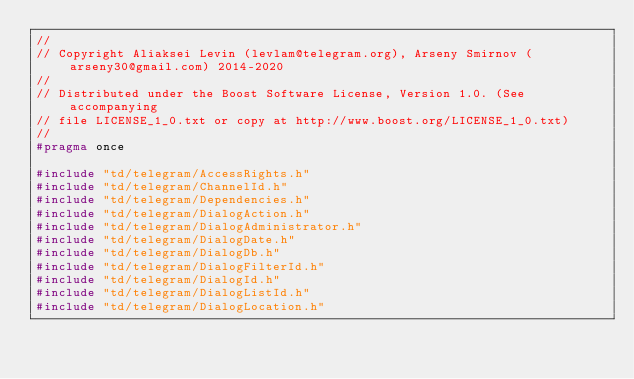<code> <loc_0><loc_0><loc_500><loc_500><_C_>//
// Copyright Aliaksei Levin (levlam@telegram.org), Arseny Smirnov (arseny30@gmail.com) 2014-2020
//
// Distributed under the Boost Software License, Version 1.0. (See accompanying
// file LICENSE_1_0.txt or copy at http://www.boost.org/LICENSE_1_0.txt)
//
#pragma once

#include "td/telegram/AccessRights.h"
#include "td/telegram/ChannelId.h"
#include "td/telegram/Dependencies.h"
#include "td/telegram/DialogAction.h"
#include "td/telegram/DialogAdministrator.h"
#include "td/telegram/DialogDate.h"
#include "td/telegram/DialogDb.h"
#include "td/telegram/DialogFilterId.h"
#include "td/telegram/DialogId.h"
#include "td/telegram/DialogListId.h"
#include "td/telegram/DialogLocation.h"</code> 